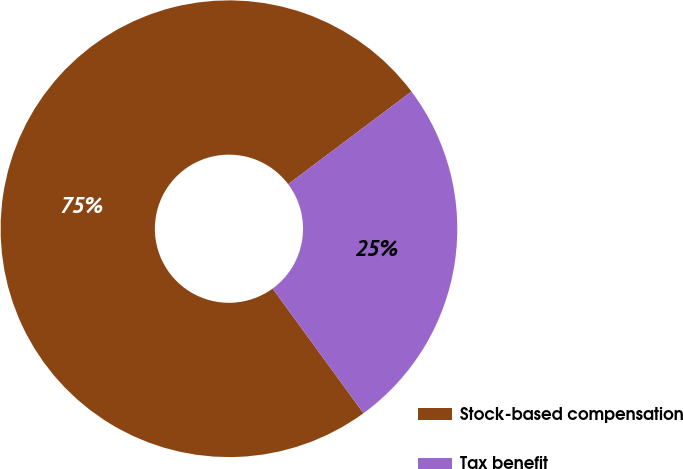Convert chart. <chart><loc_0><loc_0><loc_500><loc_500><pie_chart><fcel>Stock-based compensation<fcel>Tax benefit<nl><fcel>74.77%<fcel>25.23%<nl></chart> 